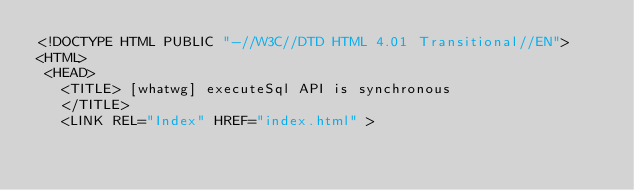<code> <loc_0><loc_0><loc_500><loc_500><_HTML_><!DOCTYPE HTML PUBLIC "-//W3C//DTD HTML 4.01 Transitional//EN">
<HTML>
 <HEAD>
   <TITLE> [whatwg] executeSql API is synchronous
   </TITLE>
   <LINK REL="Index" HREF="index.html" ></code> 